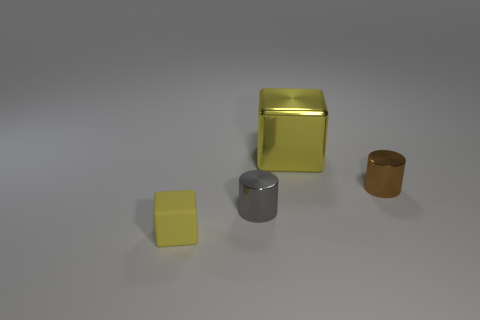There is another matte object that is the same size as the brown object; what color is it? The object you're referring to is yellow, and it has a matte finish similar to the brown object to the right, creating a harmonious yet distinct contrast between the two. 